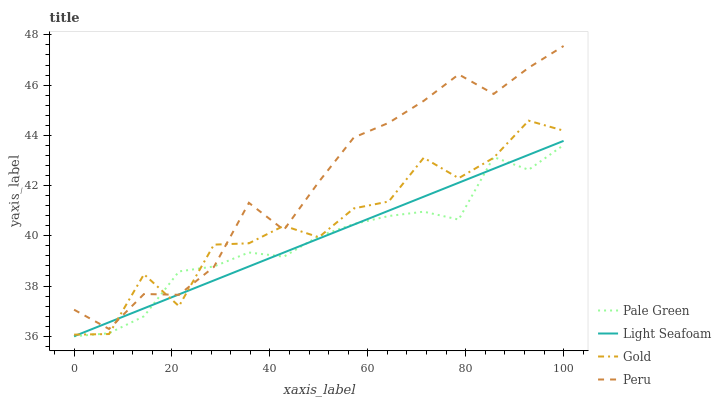Does Pale Green have the minimum area under the curve?
Answer yes or no. Yes. Does Peru have the maximum area under the curve?
Answer yes or no. Yes. Does Gold have the minimum area under the curve?
Answer yes or no. No. Does Gold have the maximum area under the curve?
Answer yes or no. No. Is Light Seafoam the smoothest?
Answer yes or no. Yes. Is Gold the roughest?
Answer yes or no. Yes. Is Pale Green the smoothest?
Answer yes or no. No. Is Pale Green the roughest?
Answer yes or no. No. Does Pale Green have the lowest value?
Answer yes or no. Yes. Does Gold have the lowest value?
Answer yes or no. No. Does Peru have the highest value?
Answer yes or no. Yes. Does Gold have the highest value?
Answer yes or no. No. Does Peru intersect Pale Green?
Answer yes or no. Yes. Is Peru less than Pale Green?
Answer yes or no. No. Is Peru greater than Pale Green?
Answer yes or no. No. 